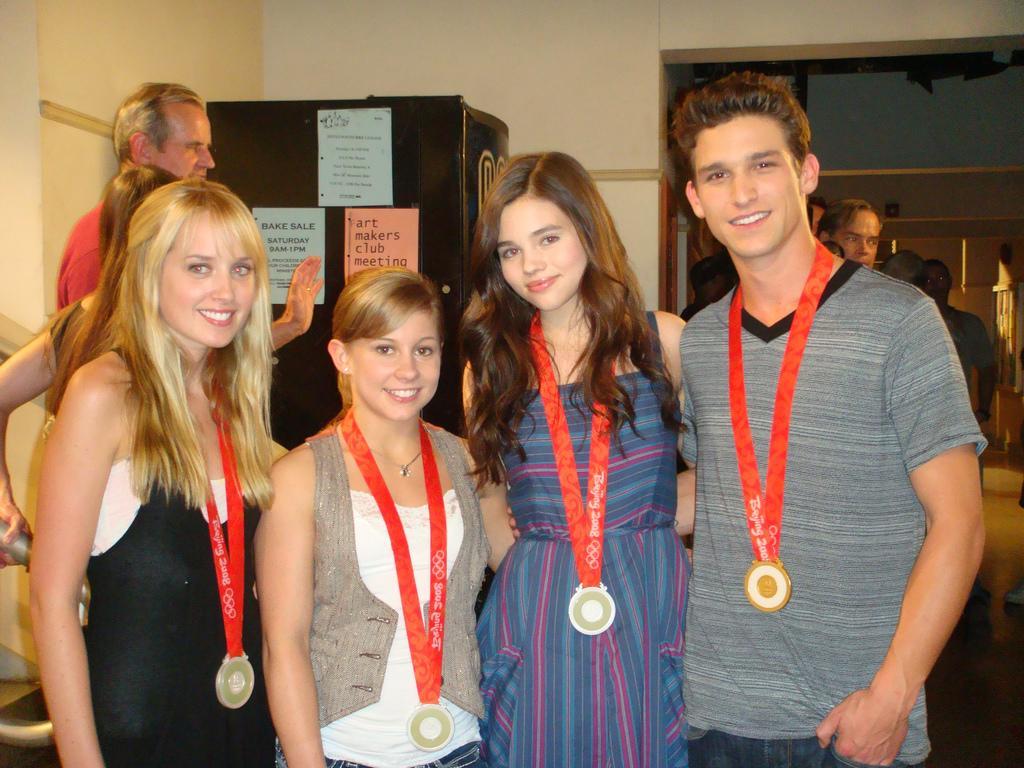Could you give a brief overview of what you see in this image? This image is taken indoors. In the background there is a wall. There is a refrigerator and there are three posters on the refrigerator. In the middle of the image three girls and a boy are standing and they are with smiling faces. In the background there are a few people. 